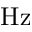<formula> <loc_0><loc_0><loc_500><loc_500>H z</formula> 